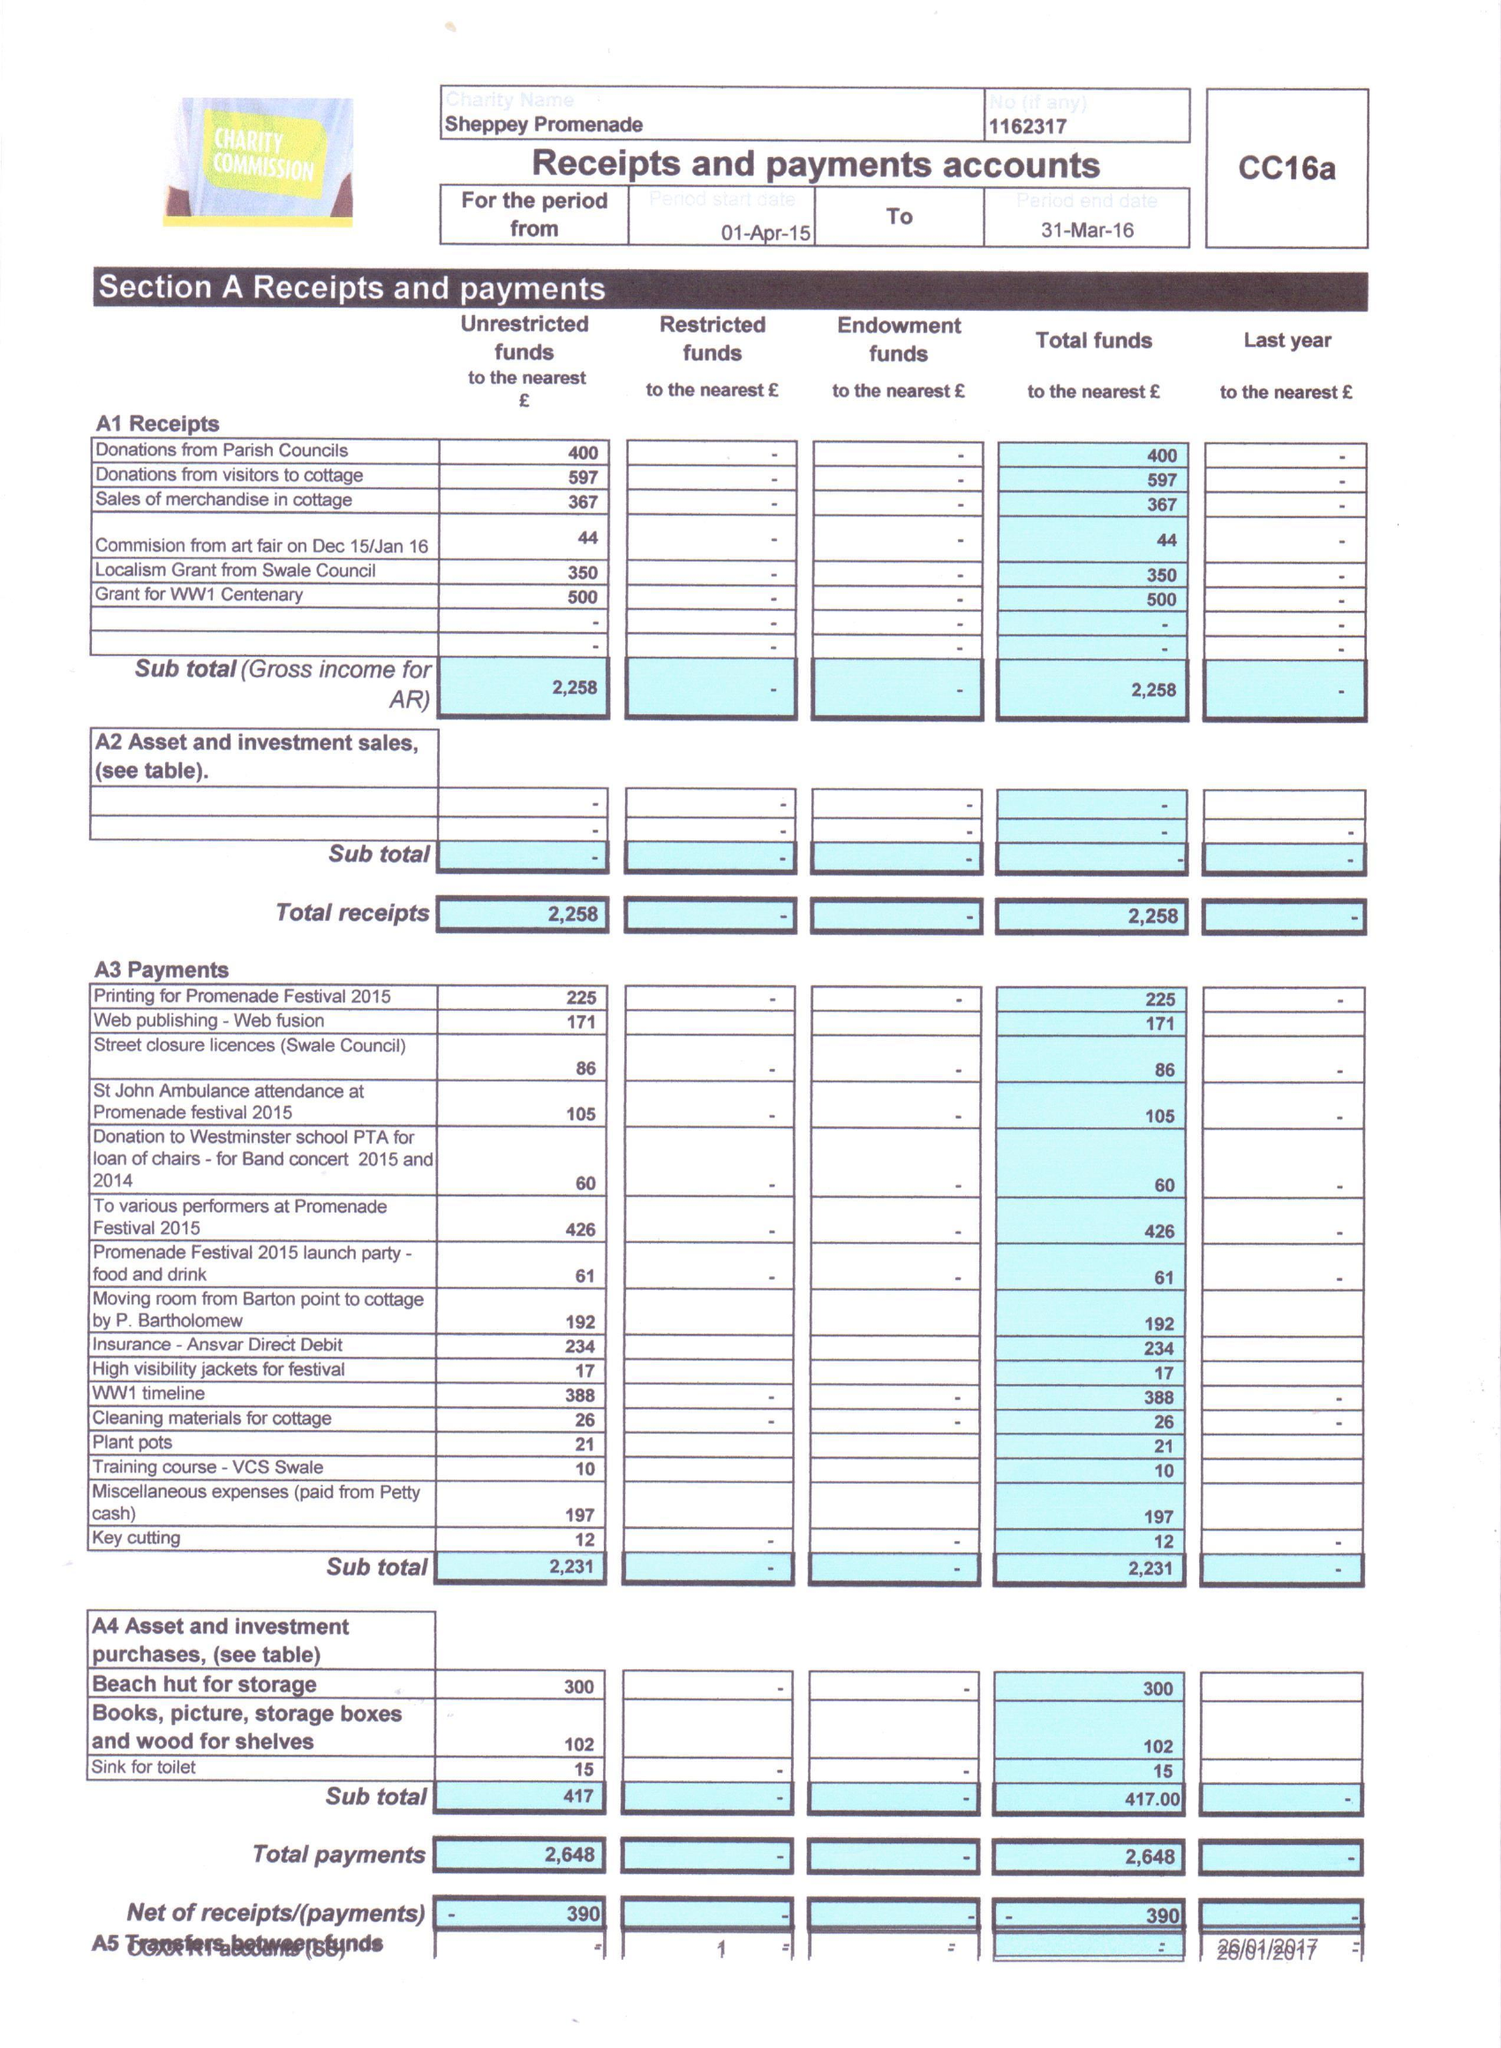What is the value for the address__postcode?
Answer the question using a single word or phrase. ME12 1AJ 